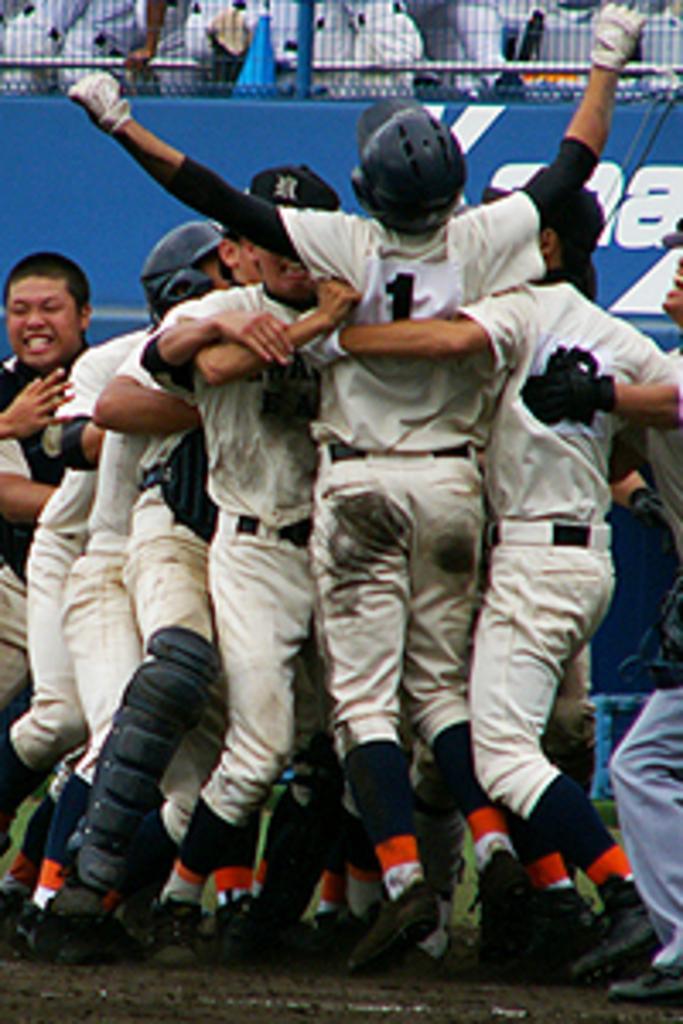Please provide a concise description of this image. In this image there are group of players who are holding each other. There is a man in the middle who is standing on the ground by raising both of his hands. In the background there is a fence. Behind the fence there are few people who are standing near the fence. 